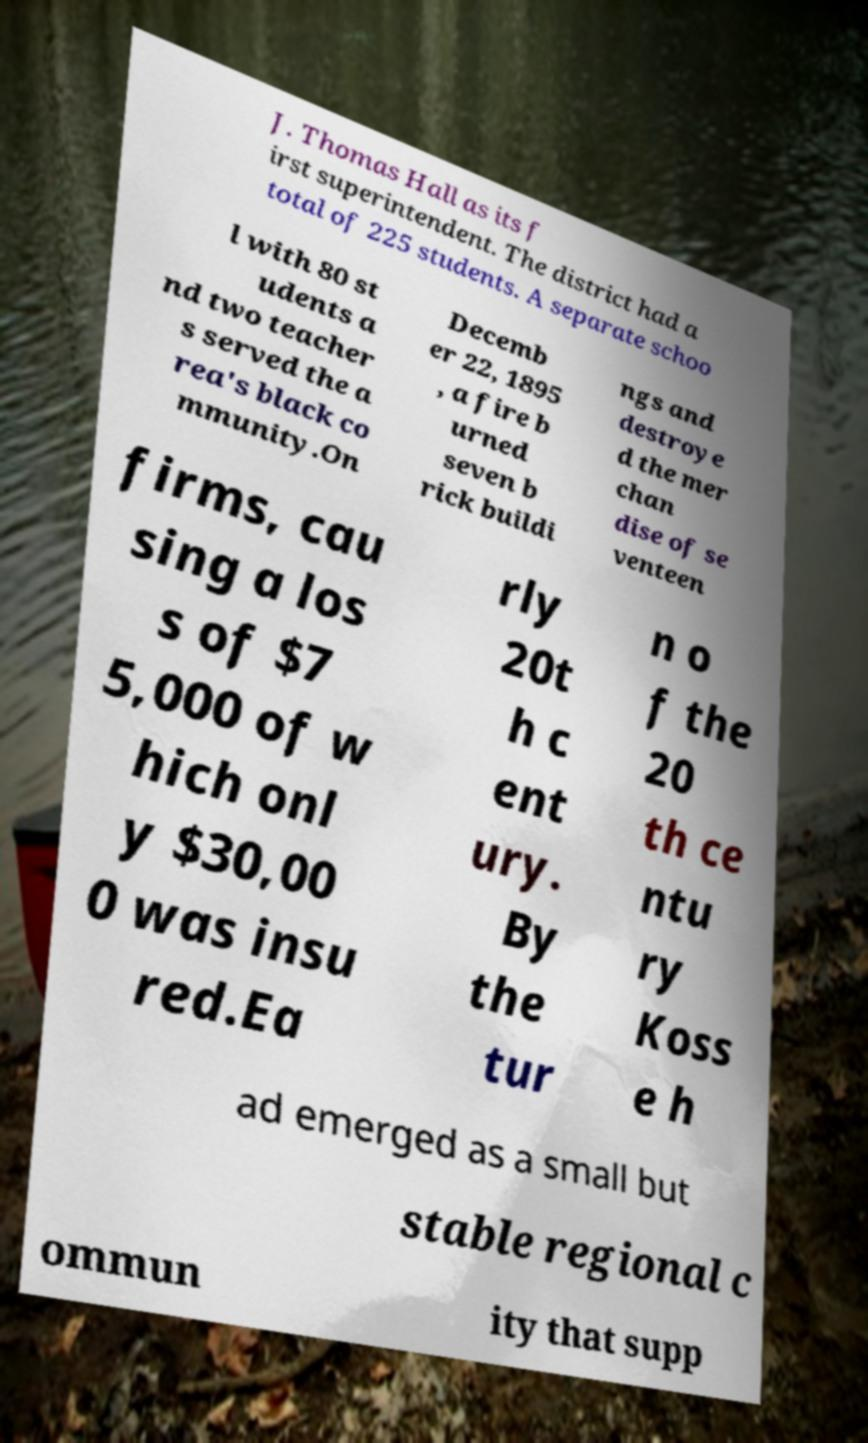Please identify and transcribe the text found in this image. J. Thomas Hall as its f irst superintendent. The district had a total of 225 students. A separate schoo l with 80 st udents a nd two teacher s served the a rea's black co mmunity.On Decemb er 22, 1895 , a fire b urned seven b rick buildi ngs and destroye d the mer chan dise of se venteen firms, cau sing a los s of $7 5,000 of w hich onl y $30,00 0 was insu red.Ea rly 20t h c ent ury. By the tur n o f the 20 th ce ntu ry Koss e h ad emerged as a small but stable regional c ommun ity that supp 